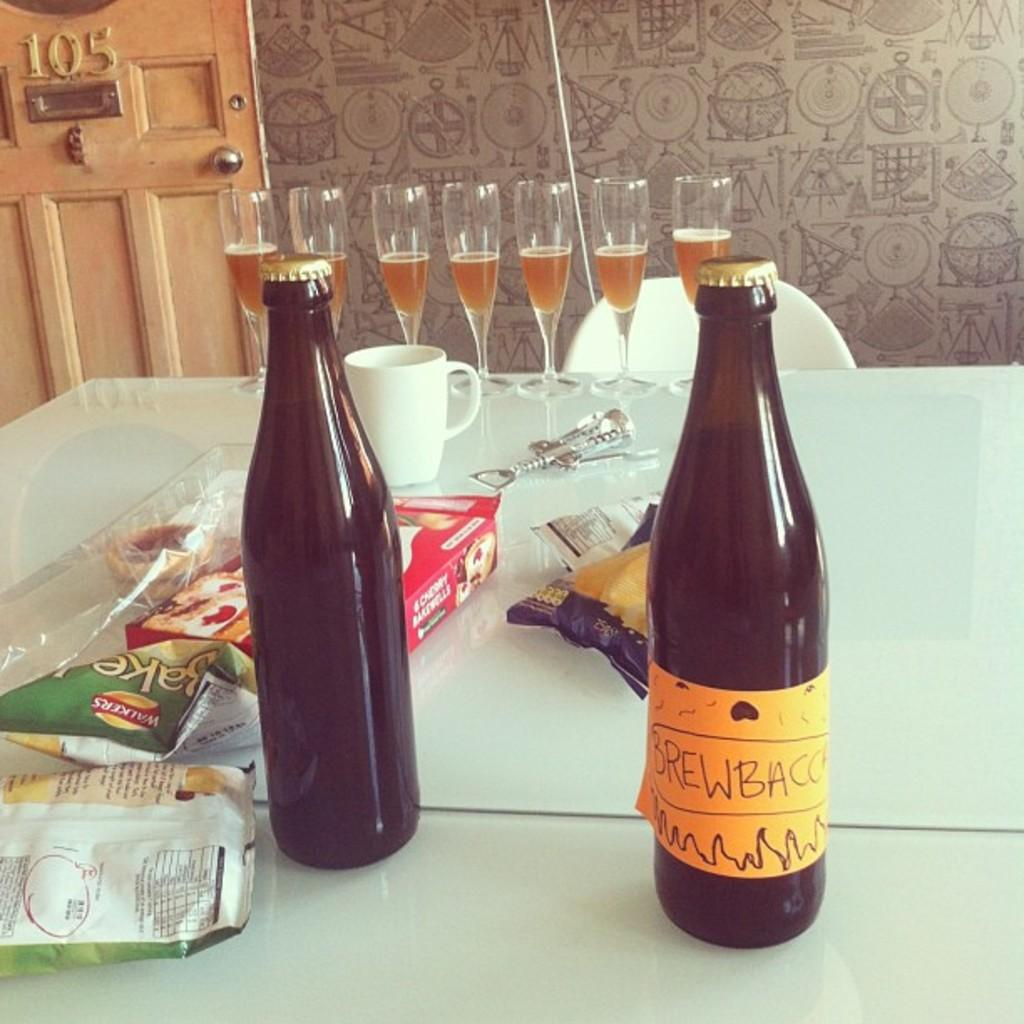<image>
Summarize the visual content of the image. two bottles of Brew Bacc on a messy table 